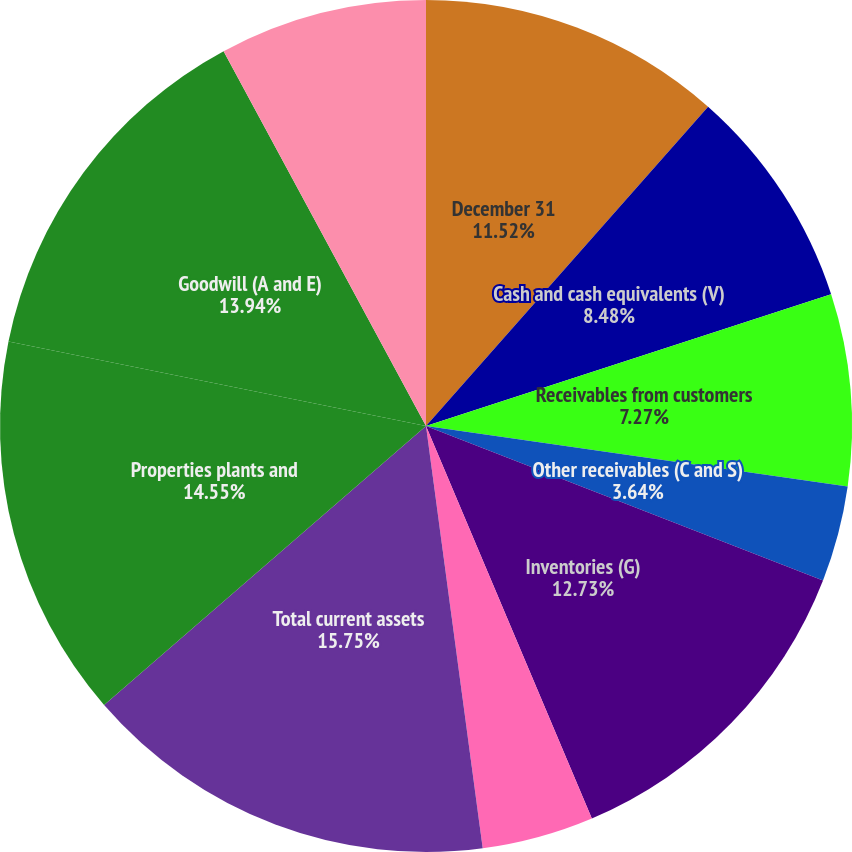<chart> <loc_0><loc_0><loc_500><loc_500><pie_chart><fcel>December 31<fcel>Cash and cash equivalents (V)<fcel>Receivables from customers<fcel>Other receivables (C and S)<fcel>Inventories (G)<fcel>Prepaid expenses and other<fcel>Total current assets<fcel>Properties plants and<fcel>Goodwill (A and E)<fcel>Deferred income taxes (R)<nl><fcel>11.52%<fcel>8.48%<fcel>7.27%<fcel>3.64%<fcel>12.73%<fcel>4.24%<fcel>15.76%<fcel>14.55%<fcel>13.94%<fcel>7.88%<nl></chart> 